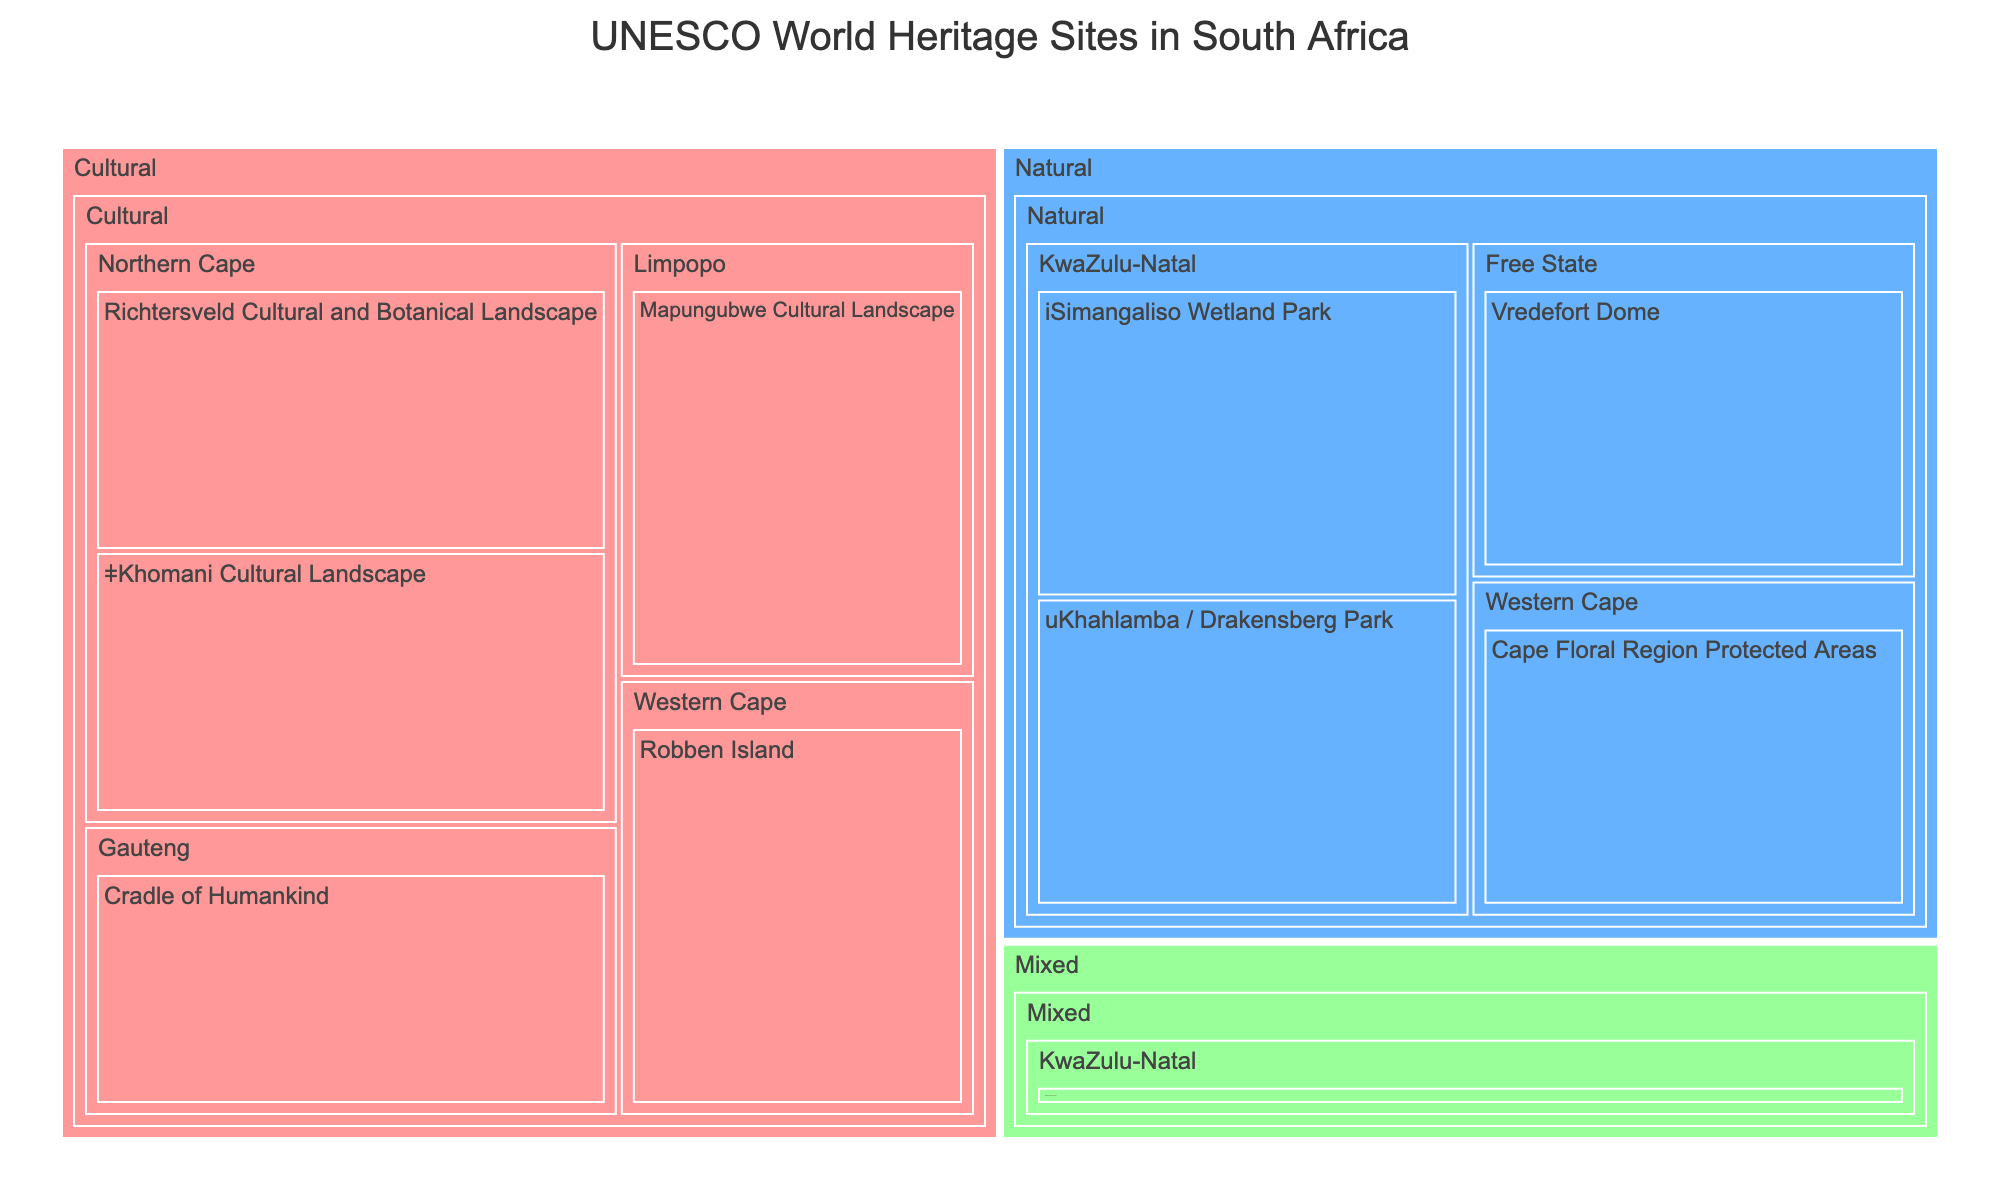What is the title of the Treemap? The title is usually located at the top of the figure and provides a summary of what the Treemap represents. In this case, it indicates the distribution of UNESCO World Heritage Sites in South Africa.
Answer: UNESCO World Heritage Sites in South Africa How many cultural heritage sites are there in South Africa according to the Treemap? Look for sections labeled under the "Cultural" category and count the number of sites listed within.
Answer: 6 Which location in South Africa has the highest number of heritage sites, and how many sites does it have? Examine the locations listed within the Treemap and count the number of sites in each. The location with the highest count is the one with the most heritage sites.
Answer: KwaZulu-Natal, 3 What is the color representation for Natural heritage sites in the Treemap? Colors are typically indicated in the legend or can be inferred by matching the color to the category label. In this Treemap, the color for natural sites is the one assigned to the "Natural" category.
Answer: Blue (#66B2FF) Which heritage site is a mixed type and where is it located? Look for the "Mixed" category in the Treemap and then identify the specific site listed under it along with its location.
Answer: Maloti-Drakensberg Park, KwaZulu-Natal How many sites are located in KwaZulu-Natal and what types are they? Identify the section of the Treemap that corresponds to KwaZulu-Natal and count the number of sites. Note their types by their color and category label.
Answer: 3 sites; 2 Natural, 1 Mixed Which type has fewer sites, Mixed or Natural? Compare the number of sites listed under "Mixed" and "Natural" categories in the Treemap.
Answer: Mixed Among the categories, Cultural, Natural, and Mixed, which one appears the largest in terms of the number of sites? Evaluate the number of sites listed under each category. The category with the most sites is the largest.
Answer: Cultural Which location has both Cultural and Natural heritage sites, and how many of each type does it have? Check the Treemap for locations that list both types of sites and count the number of each type at that location.
Answer: Western Cape; 1 Cultural, 1 Natural Find the distribution of sites across different locations. Which location has the least number of sites and how many does it have? Look at the various locations listed in the Treemap and count the number of sites in each. The location with the fewest sites will be identified this way.
Answer: Free State, 1 